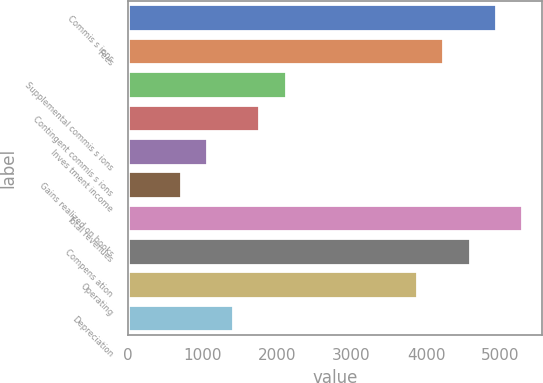<chart> <loc_0><loc_0><loc_500><loc_500><bar_chart><fcel>Commis s ions<fcel>Fees<fcel>Supplemental commis s ions<fcel>Contingent commis s ions<fcel>Inves tment income<fcel>Gains realized on books<fcel>Total revenues<fcel>Compens ation<fcel>Operating<fcel>Depreciation<nl><fcel>4938.24<fcel>4233.06<fcel>2117.52<fcel>1764.93<fcel>1059.75<fcel>707.16<fcel>5290.83<fcel>4585.65<fcel>3880.47<fcel>1412.34<nl></chart> 